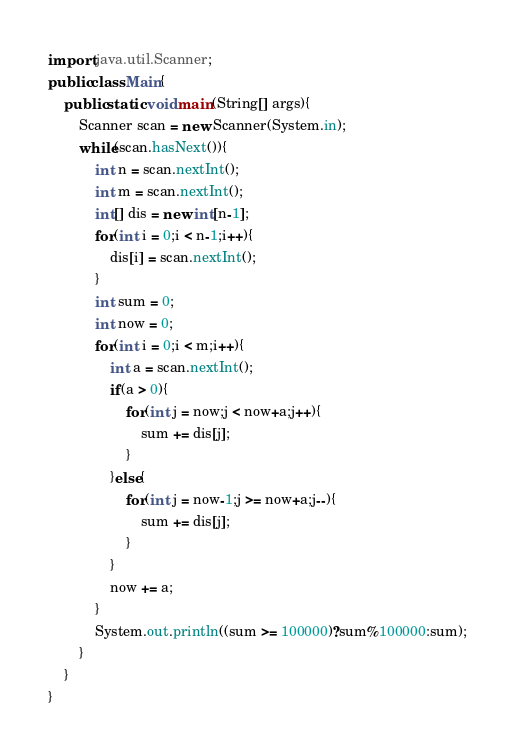<code> <loc_0><loc_0><loc_500><loc_500><_Java_>import java.util.Scanner;
public class Main{
	public static void main(String[] args){
		Scanner scan = new Scanner(System.in);
		while(scan.hasNext()){
			int n = scan.nextInt();
			int m = scan.nextInt();
			int[] dis = new int[n-1];
			for(int i = 0;i < n-1;i++){
				dis[i] = scan.nextInt();
			}
			int sum = 0;
			int now = 0;
			for(int i = 0;i < m;i++){
				int a = scan.nextInt();
				if(a > 0){
					for(int j = now;j < now+a;j++){
						sum += dis[j];
					}
				}else{
					for(int j = now-1;j >= now+a;j--){
						sum += dis[j];
					}
				}
				now += a;
			}
			System.out.println((sum >= 100000)?sum%100000:sum);
		}
	}
}</code> 